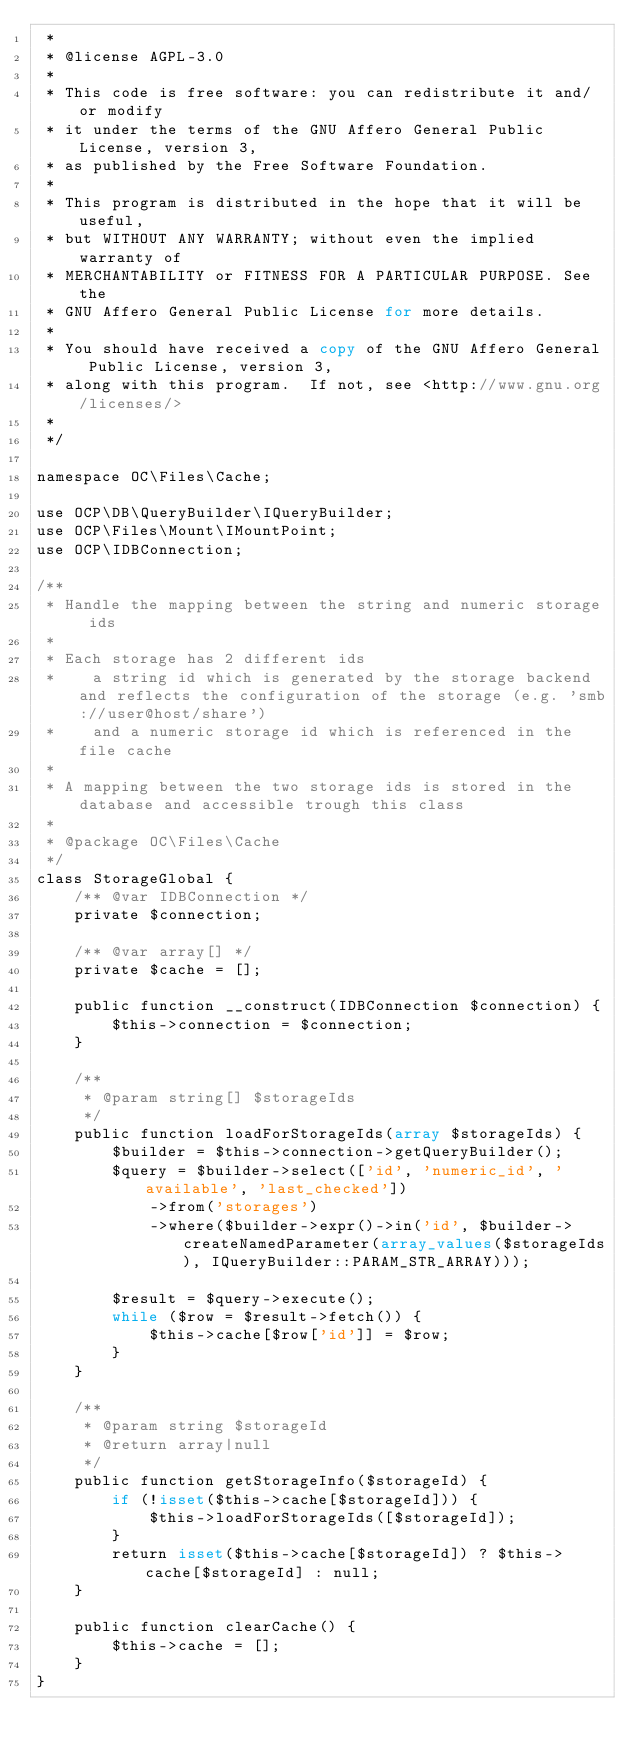<code> <loc_0><loc_0><loc_500><loc_500><_PHP_> *
 * @license AGPL-3.0
 *
 * This code is free software: you can redistribute it and/or modify
 * it under the terms of the GNU Affero General Public License, version 3,
 * as published by the Free Software Foundation.
 *
 * This program is distributed in the hope that it will be useful,
 * but WITHOUT ANY WARRANTY; without even the implied warranty of
 * MERCHANTABILITY or FITNESS FOR A PARTICULAR PURPOSE. See the
 * GNU Affero General Public License for more details.
 *
 * You should have received a copy of the GNU Affero General Public License, version 3,
 * along with this program.  If not, see <http://www.gnu.org/licenses/>
 *
 */

namespace OC\Files\Cache;

use OCP\DB\QueryBuilder\IQueryBuilder;
use OCP\Files\Mount\IMountPoint;
use OCP\IDBConnection;

/**
 * Handle the mapping between the string and numeric storage ids
 *
 * Each storage has 2 different ids
 *    a string id which is generated by the storage backend and reflects the configuration of the storage (e.g. 'smb://user@host/share')
 *    and a numeric storage id which is referenced in the file cache
 *
 * A mapping between the two storage ids is stored in the database and accessible trough this class
 *
 * @package OC\Files\Cache
 */
class StorageGlobal {
	/** @var IDBConnection */
	private $connection;

	/** @var array[] */
	private $cache = [];

	public function __construct(IDBConnection $connection) {
		$this->connection = $connection;
	}

	/**
	 * @param string[] $storageIds
	 */
	public function loadForStorageIds(array $storageIds) {
		$builder = $this->connection->getQueryBuilder();
		$query = $builder->select(['id', 'numeric_id', 'available', 'last_checked'])
			->from('storages')
			->where($builder->expr()->in('id', $builder->createNamedParameter(array_values($storageIds), IQueryBuilder::PARAM_STR_ARRAY)));

		$result = $query->execute();
		while ($row = $result->fetch()) {
			$this->cache[$row['id']] = $row;
		}
	}

	/**
	 * @param string $storageId
	 * @return array|null
	 */
	public function getStorageInfo($storageId) {
		if (!isset($this->cache[$storageId])) {
			$this->loadForStorageIds([$storageId]);
		}
		return isset($this->cache[$storageId]) ? $this->cache[$storageId] : null;
	}

	public function clearCache() {
		$this->cache = [];
	}
}
</code> 